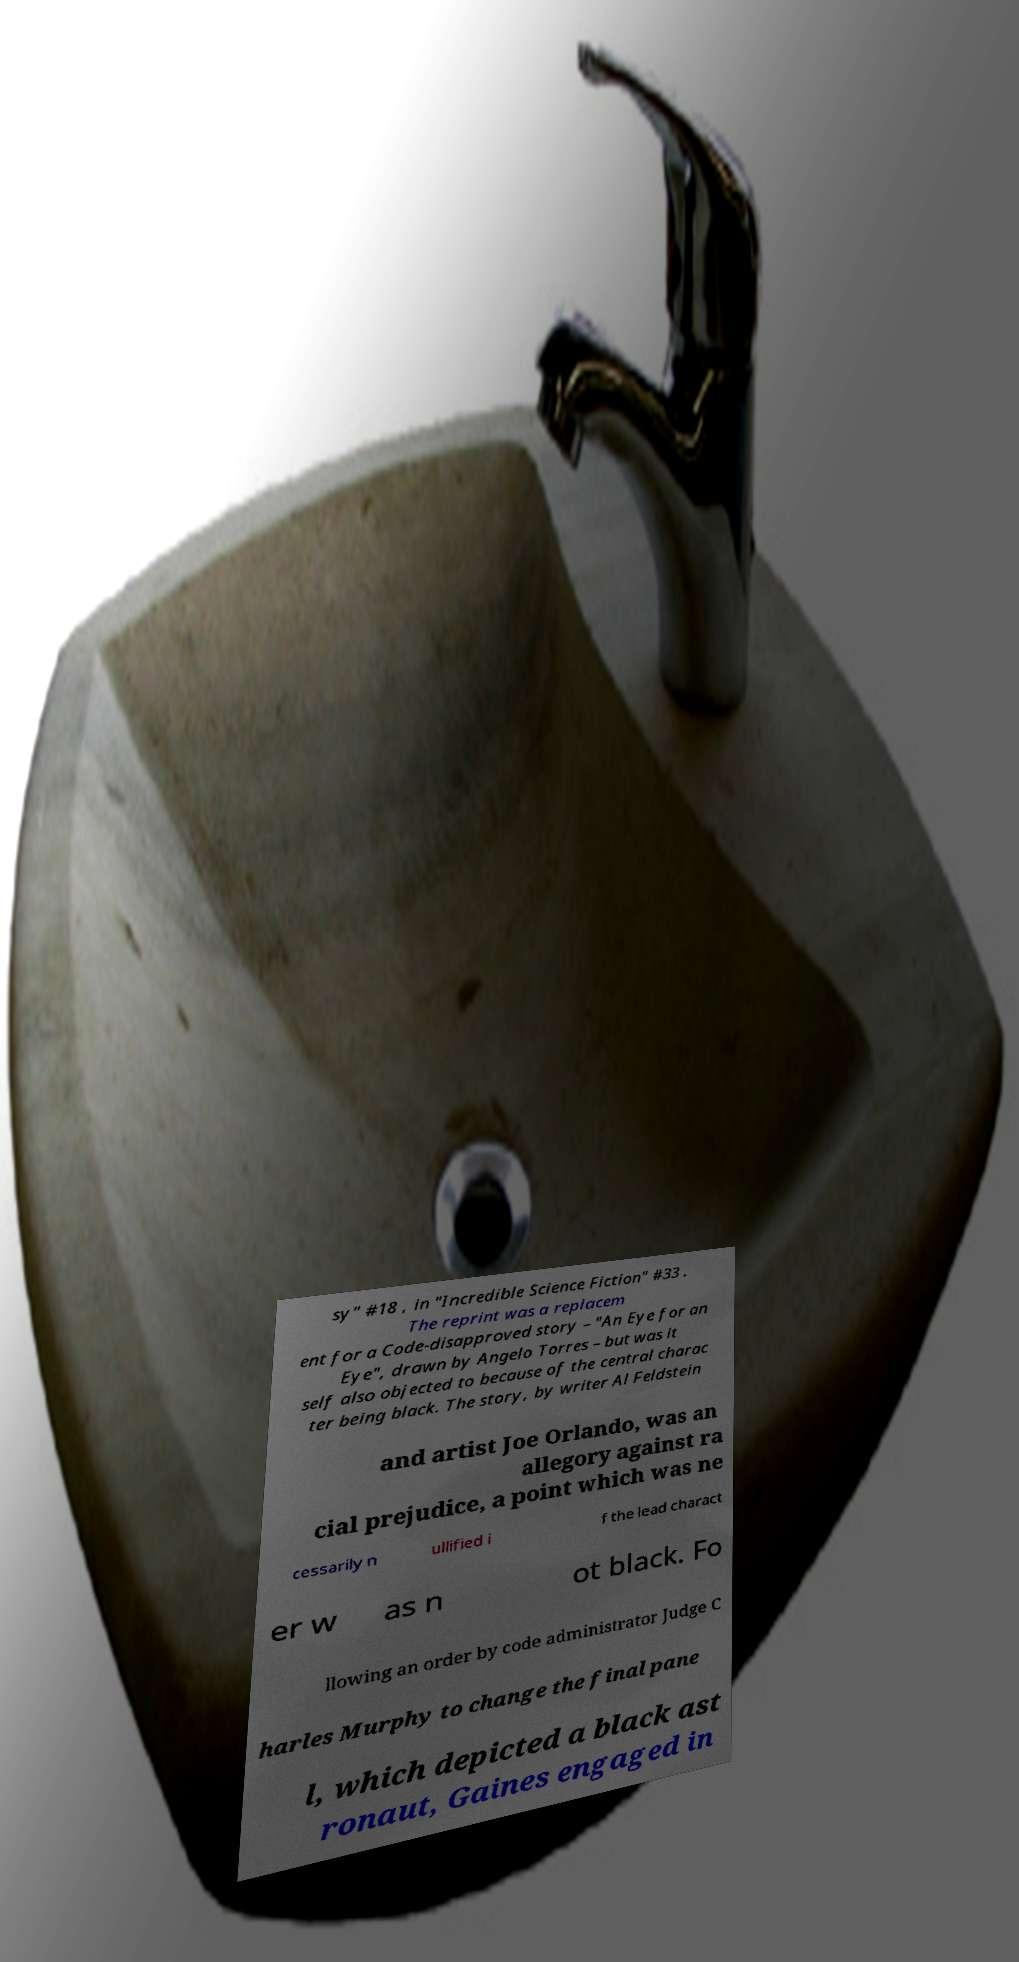For documentation purposes, I need the text within this image transcribed. Could you provide that? sy" #18 , in "Incredible Science Fiction" #33 . The reprint was a replacem ent for a Code-disapproved story – "An Eye for an Eye", drawn by Angelo Torres – but was it self also objected to because of the central charac ter being black. The story, by writer Al Feldstein and artist Joe Orlando, was an allegory against ra cial prejudice, a point which was ne cessarily n ullified i f the lead charact er w as n ot black. Fo llowing an order by code administrator Judge C harles Murphy to change the final pane l, which depicted a black ast ronaut, Gaines engaged in 